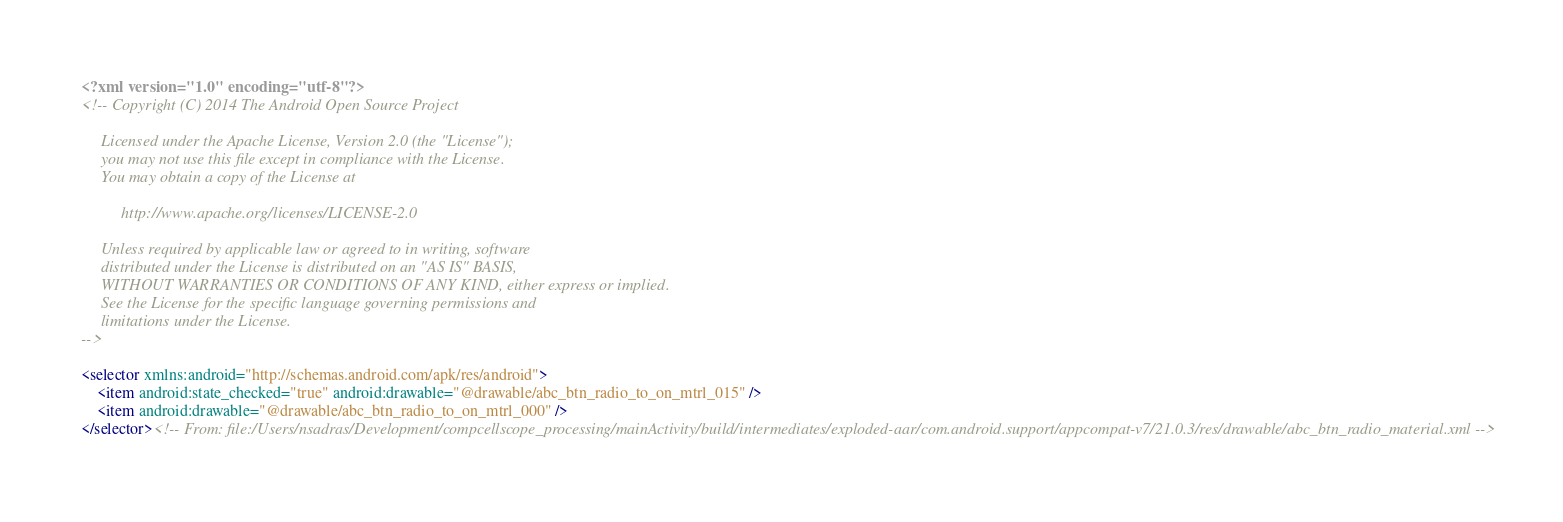Convert code to text. <code><loc_0><loc_0><loc_500><loc_500><_XML_><?xml version="1.0" encoding="utf-8"?>
<!-- Copyright (C) 2014 The Android Open Source Project

     Licensed under the Apache License, Version 2.0 (the "License");
     you may not use this file except in compliance with the License.
     You may obtain a copy of the License at

          http://www.apache.org/licenses/LICENSE-2.0

     Unless required by applicable law or agreed to in writing, software
     distributed under the License is distributed on an "AS IS" BASIS,
     WITHOUT WARRANTIES OR CONDITIONS OF ANY KIND, either express or implied.
     See the License for the specific language governing permissions and
     limitations under the License.
-->

<selector xmlns:android="http://schemas.android.com/apk/res/android">
    <item android:state_checked="true" android:drawable="@drawable/abc_btn_radio_to_on_mtrl_015" />
    <item android:drawable="@drawable/abc_btn_radio_to_on_mtrl_000" />
</selector><!-- From: file:/Users/nsadras/Development/compcellscope_processing/mainActivity/build/intermediates/exploded-aar/com.android.support/appcompat-v7/21.0.3/res/drawable/abc_btn_radio_material.xml --></code> 